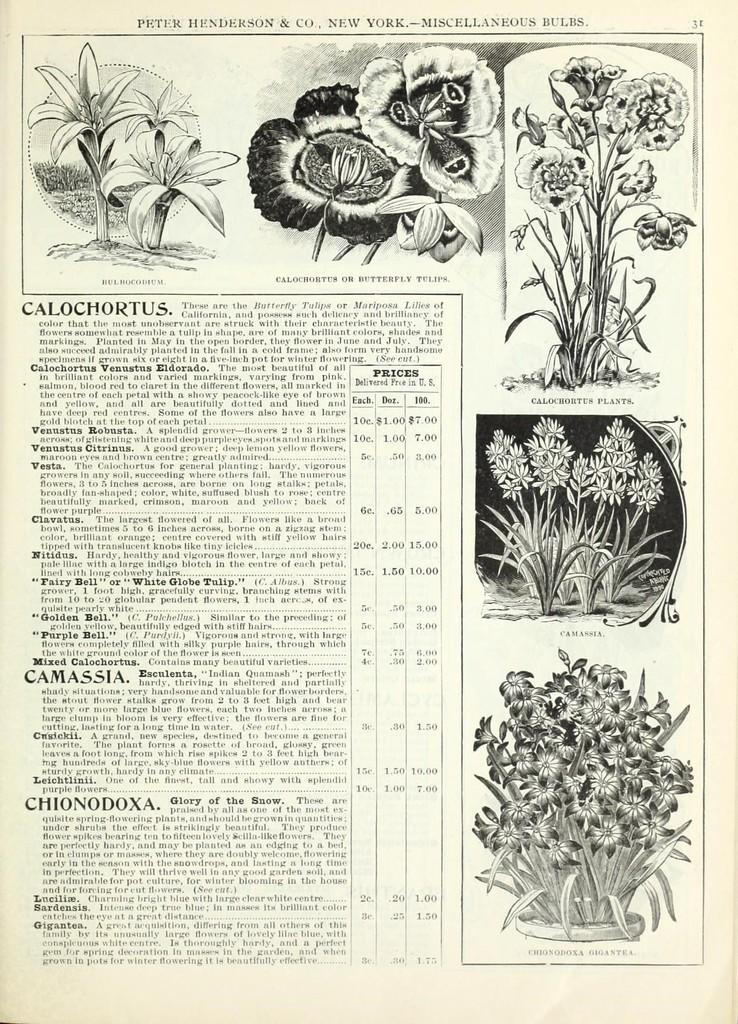What is the main subject of the picture? The main subject of the picture is a magazine. What type of content is featured in the magazine? The magazine contains images of flowers and plants, as well as information about them. Reasoning: Leting: Let's think step by step in order to produce the conversation. We start by identifying the main subject of the image, which is the magazine. Then, we describe the content of the magazine, focusing on the images and information about flowers and plants. Each question is designed to elicit a specific detail about the image that is known from the provided facts. Absurd Question/Answer: Can you tell me how many ants are crawling on the metal scene in the image? There are no ants or metal scenes present in the image; it features a magazine with images and information about flowers and plants. What type of metal is used to create the scene in the image? There is no metal scene present in the image; it features a magazine with images and information about flowers and plants. 